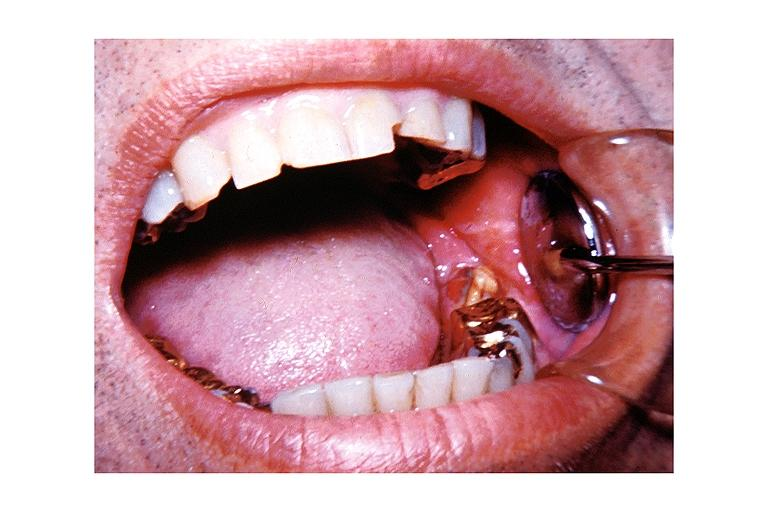does artery show chronic osteomyelitis?
Answer the question using a single word or phrase. No 